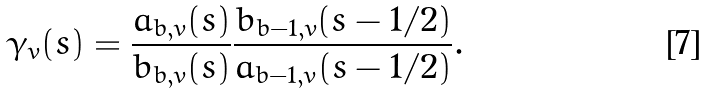<formula> <loc_0><loc_0><loc_500><loc_500>\gamma _ { v } ( s ) = \frac { a _ { b , v } ( s ) } { b _ { b , v } ( s ) } \frac { b _ { b - 1 , v } ( s - 1 / 2 ) } { a _ { b - 1 , v } ( s - 1 / 2 ) } .</formula> 